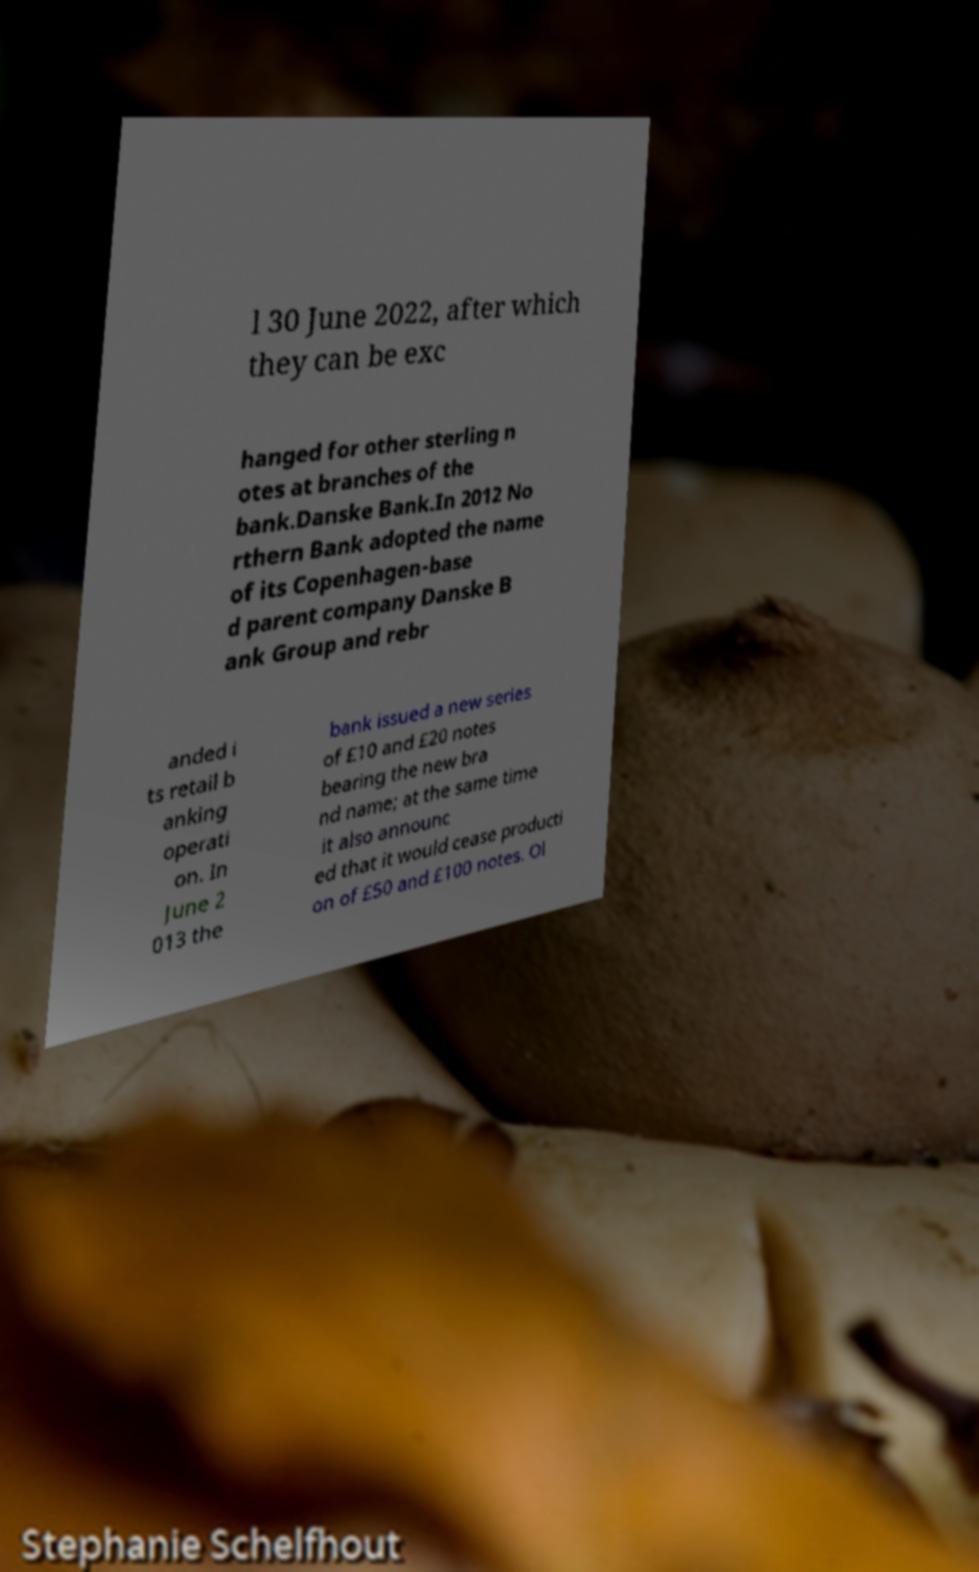For documentation purposes, I need the text within this image transcribed. Could you provide that? l 30 June 2022, after which they can be exc hanged for other sterling n otes at branches of the bank.Danske Bank.In 2012 No rthern Bank adopted the name of its Copenhagen-base d parent company Danske B ank Group and rebr anded i ts retail b anking operati on. In June 2 013 the bank issued a new series of £10 and £20 notes bearing the new bra nd name; at the same time it also announc ed that it would cease producti on of £50 and £100 notes. Ol 